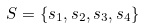<formula> <loc_0><loc_0><loc_500><loc_500>S = \{ s _ { 1 } , s _ { 2 } , s _ { 3 } , s _ { 4 } \}</formula> 